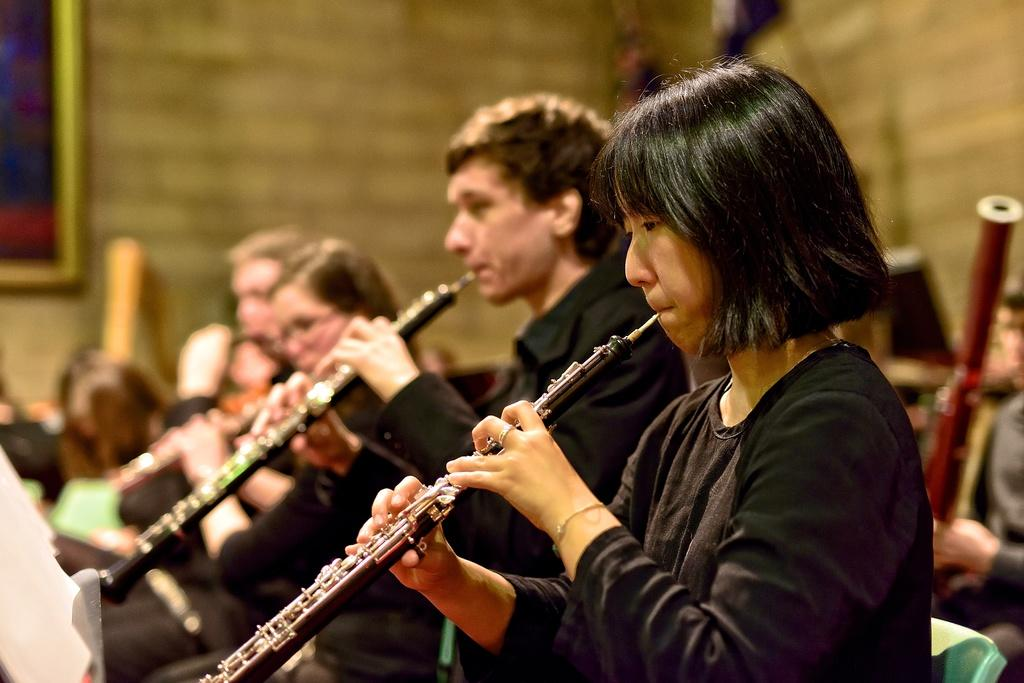What are the people in the image doing? The people in the image are holding musical instruments. What can be seen on the left side of the image? There is a frame attached to the wall on the left side of the image. What is located at the bottom left corner of the image? There is a book on the left bottom of the image. How much sand is visible in the image? There is no sand present in the image. What type of addition can be seen being performed by the people in the image? The people in the image are not performing any addition; they are holding musical instruments. 